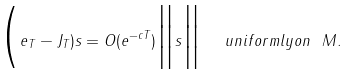Convert formula to latex. <formula><loc_0><loc_0><loc_500><loc_500>\Big ( e _ { T } - J _ { T } ) s = O ( e ^ { - c T } ) \Big \| s \Big \| \ \ u n i f o r m l y o n \ M .</formula> 